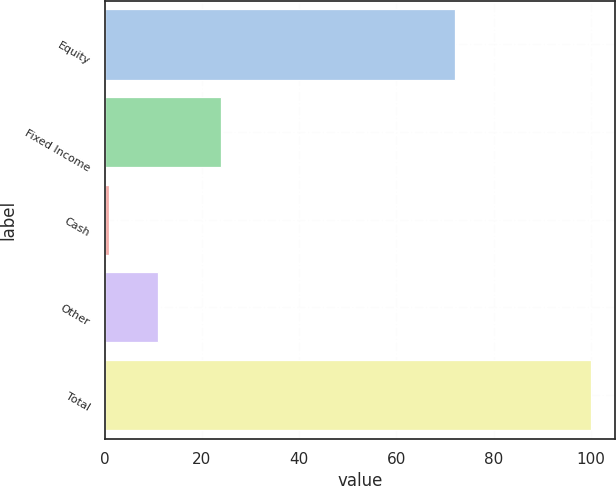<chart> <loc_0><loc_0><loc_500><loc_500><bar_chart><fcel>Equity<fcel>Fixed Income<fcel>Cash<fcel>Other<fcel>Total<nl><fcel>72<fcel>24<fcel>1<fcel>10.9<fcel>100<nl></chart> 